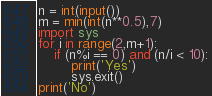Convert code to text. <code><loc_0><loc_0><loc_500><loc_500><_Python_>n = int(input())
m = min(int(n**0.5),7)
import sys
for i in range(2,m+1):
    if (n%i == 0) and (n/i < 10):
        print('Yes')
        sys.exit()
print('No')</code> 